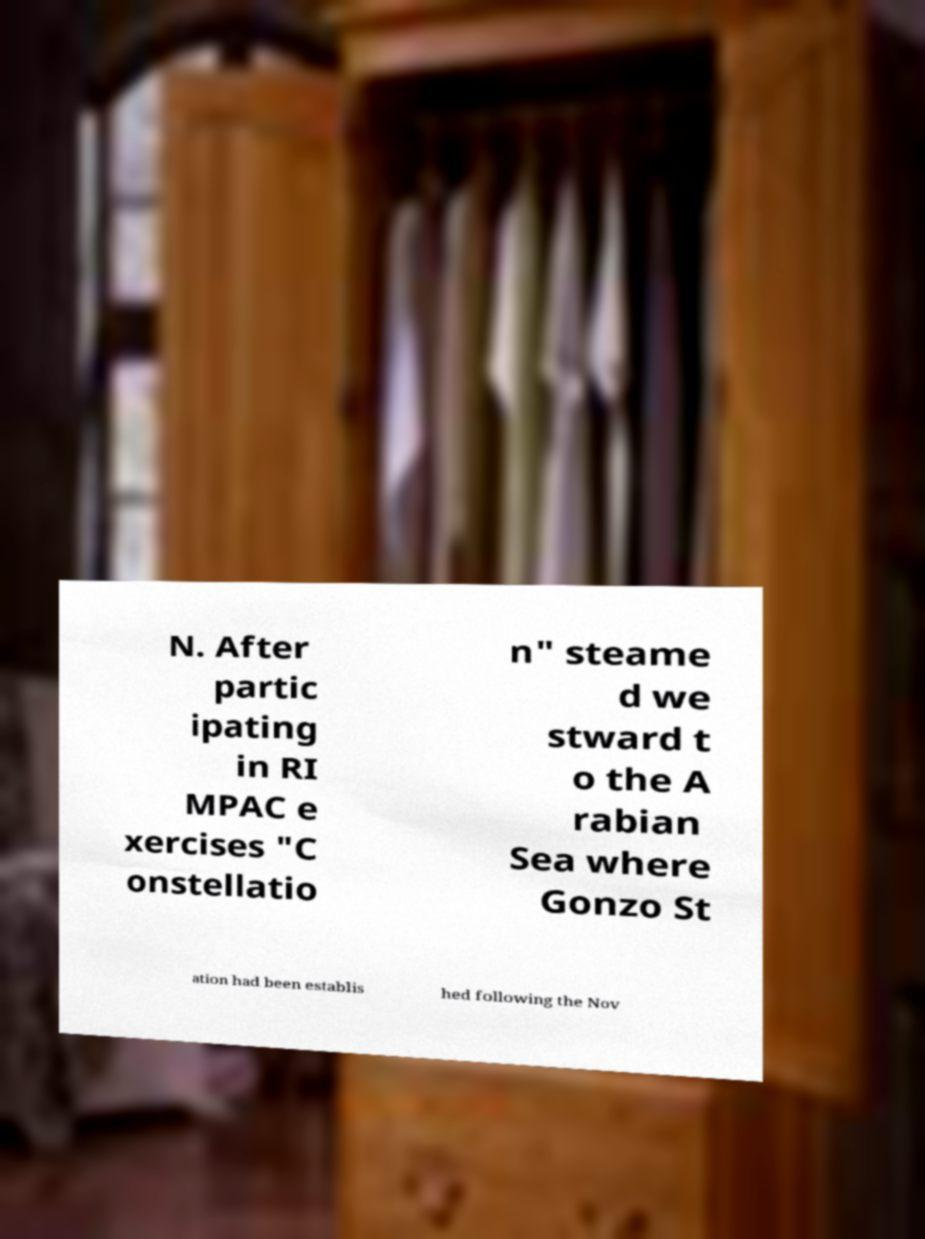There's text embedded in this image that I need extracted. Can you transcribe it verbatim? N. After partic ipating in RI MPAC e xercises "C onstellatio n" steame d we stward t o the A rabian Sea where Gonzo St ation had been establis hed following the Nov 